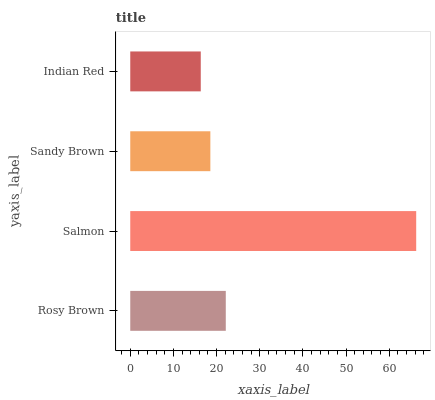Is Indian Red the minimum?
Answer yes or no. Yes. Is Salmon the maximum?
Answer yes or no. Yes. Is Sandy Brown the minimum?
Answer yes or no. No. Is Sandy Brown the maximum?
Answer yes or no. No. Is Salmon greater than Sandy Brown?
Answer yes or no. Yes. Is Sandy Brown less than Salmon?
Answer yes or no. Yes. Is Sandy Brown greater than Salmon?
Answer yes or no. No. Is Salmon less than Sandy Brown?
Answer yes or no. No. Is Rosy Brown the high median?
Answer yes or no. Yes. Is Sandy Brown the low median?
Answer yes or no. Yes. Is Salmon the high median?
Answer yes or no. No. Is Indian Red the low median?
Answer yes or no. No. 